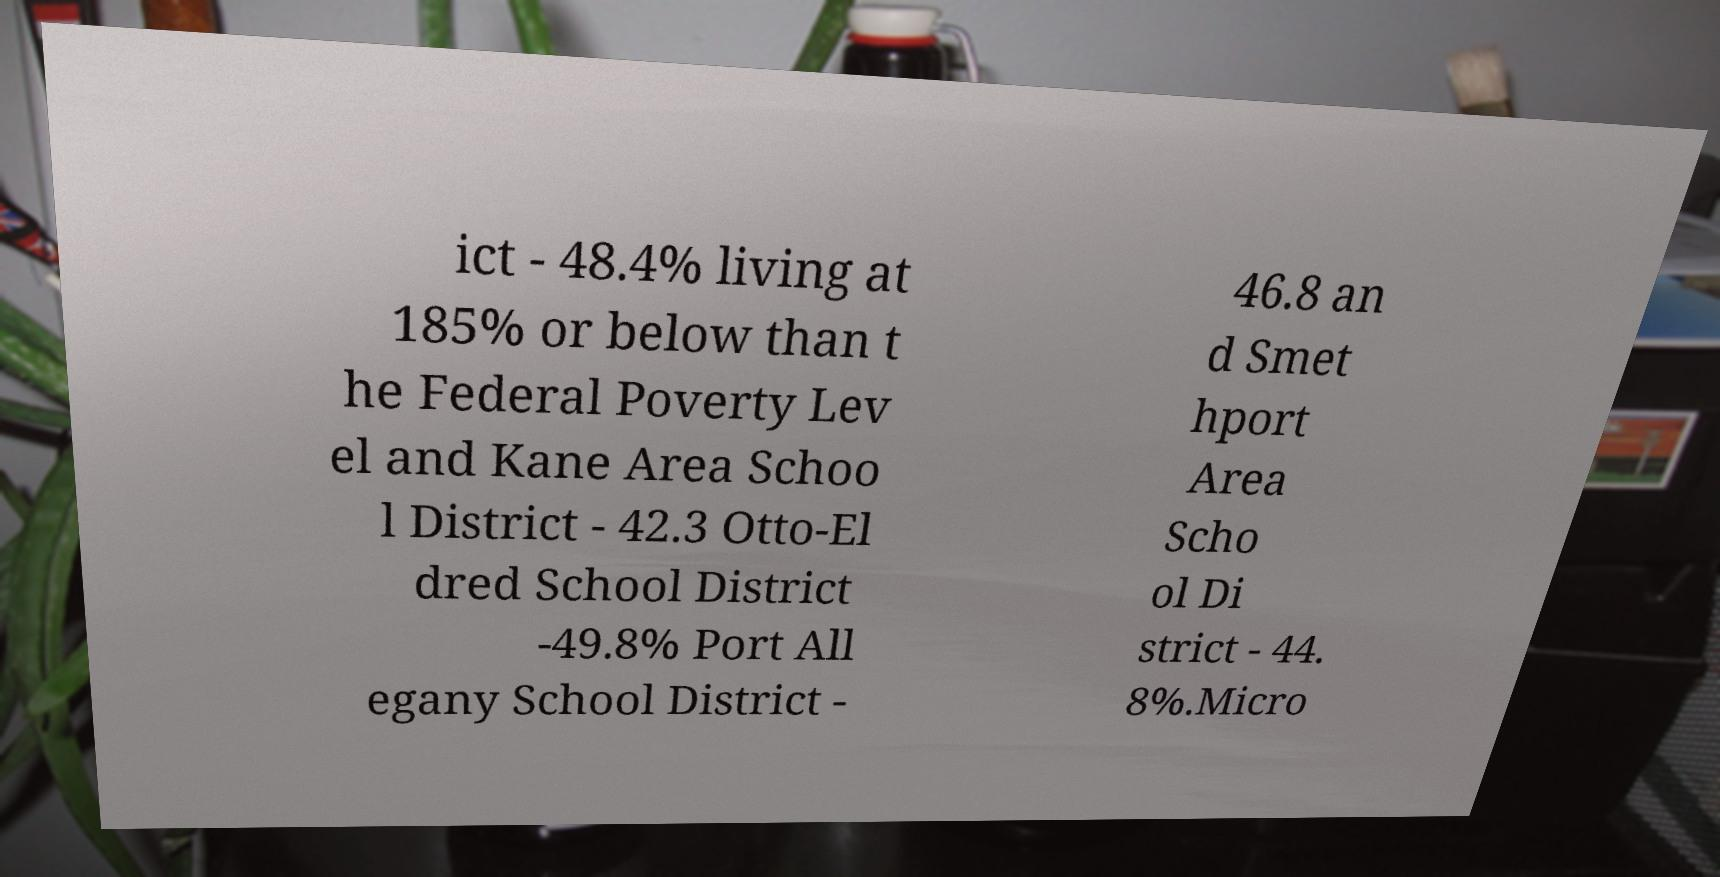Please identify and transcribe the text found in this image. ict - 48.4% living at 185% or below than t he Federal Poverty Lev el and Kane Area Schoo l District - 42.3 Otto-El dred School District -49.8% Port All egany School District - 46.8 an d Smet hport Area Scho ol Di strict - 44. 8%.Micro 